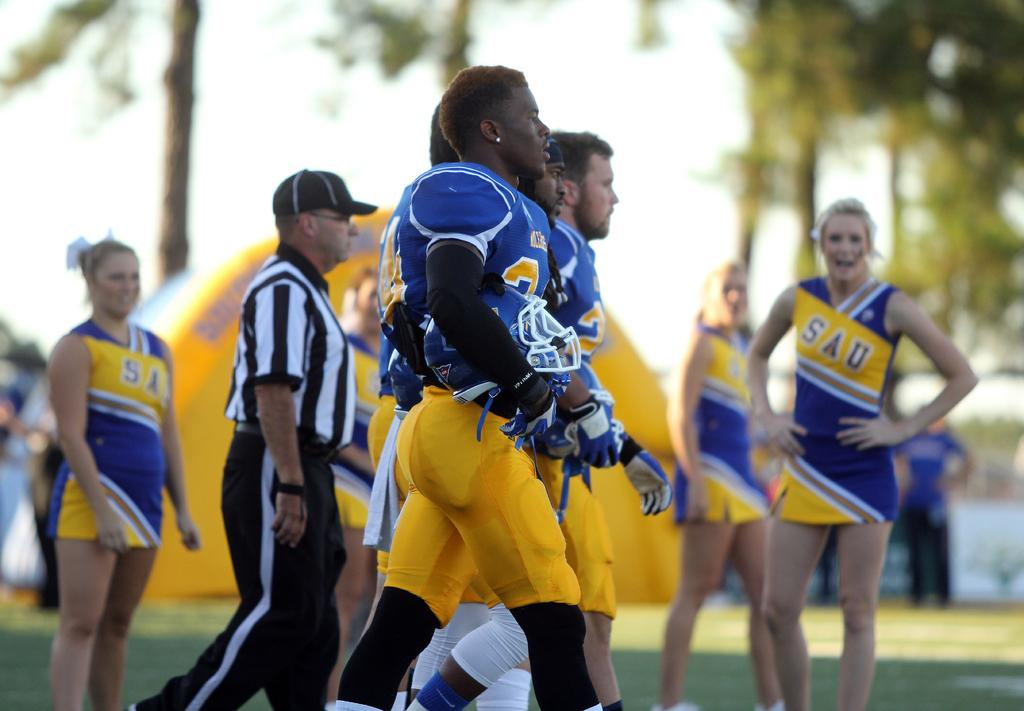<image>
Relay a brief, clear account of the picture shown. Cheerleaders in the distance watch as the SAU football team players march towards the field. 